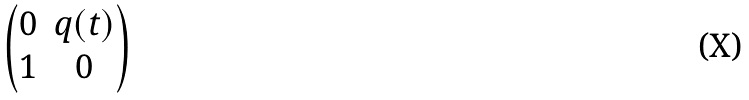<formula> <loc_0><loc_0><loc_500><loc_500>\begin{pmatrix} 0 & q ( t ) \\ 1 & 0 \end{pmatrix}</formula> 